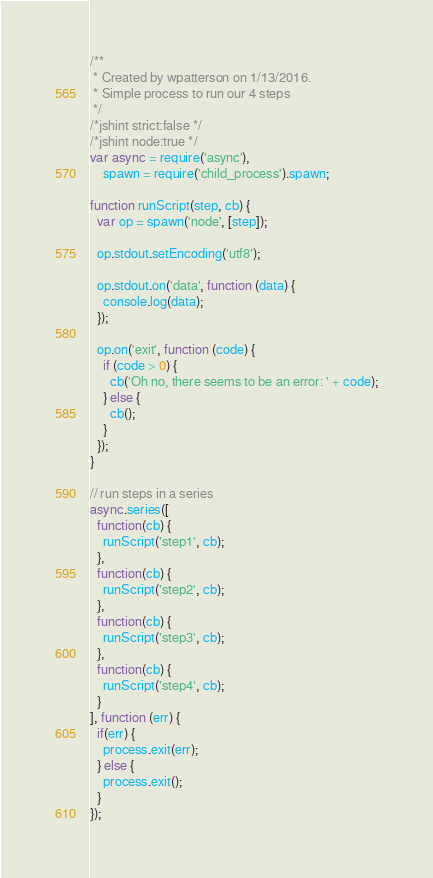<code> <loc_0><loc_0><loc_500><loc_500><_JavaScript_>/**
 * Created by wpatterson on 1/13/2016.
 * Simple process to run our 4 steps
 */
/*jshint strict:false */
/*jshint node:true */
var async = require('async'),
    spawn = require('child_process').spawn;

function runScript(step, cb) {
  var op = spawn('node', [step]);

  op.stdout.setEncoding('utf8');

  op.stdout.on('data', function (data) {
    console.log(data);
  });

  op.on('exit', function (code) {
    if (code > 0) {
      cb('Oh no, there seems to be an error: ' + code);
    } else {
      cb();
    }
  });
}

// run steps in a series
async.series([
  function(cb) {
    runScript('step1', cb);
  },
  function(cb) {
    runScript('step2', cb);
  },
  function(cb) {
    runScript('step3', cb);
  },
  function(cb) {
    runScript('step4', cb);
  }
], function (err) {
  if(err) {
    process.exit(err);
  } else {
    process.exit();
  }
});
</code> 